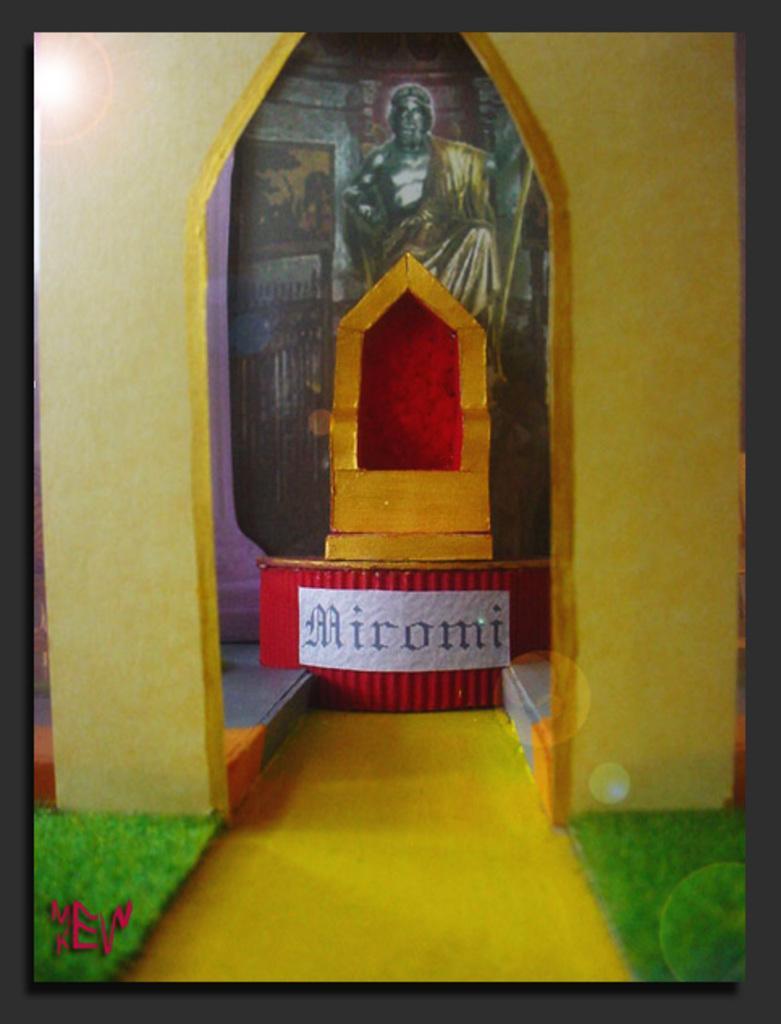Please provide a concise description of this image. There is a chair arranged on a stage. In front of this, there is a wall. In front of this will, there's grass on both sides of the path. In the background, there is painting on the wall. 